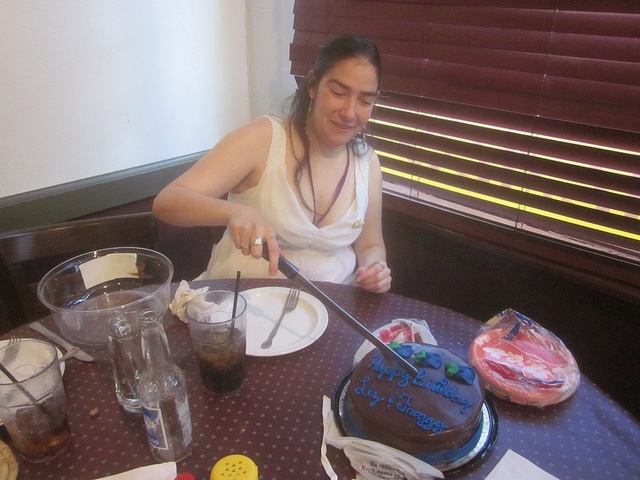Describe the objects in this image and their specific colors. I can see dining table in lightgray, maroon, gray, blue, and darkgray tones, people in lightgray, tan, gray, and darkgray tones, cake in lightgray, black, purple, and gray tones, bowl in lightgray, gray, black, and tan tones, and cup in lightgray, maroon, darkgray, gray, and tan tones in this image. 